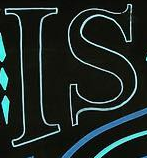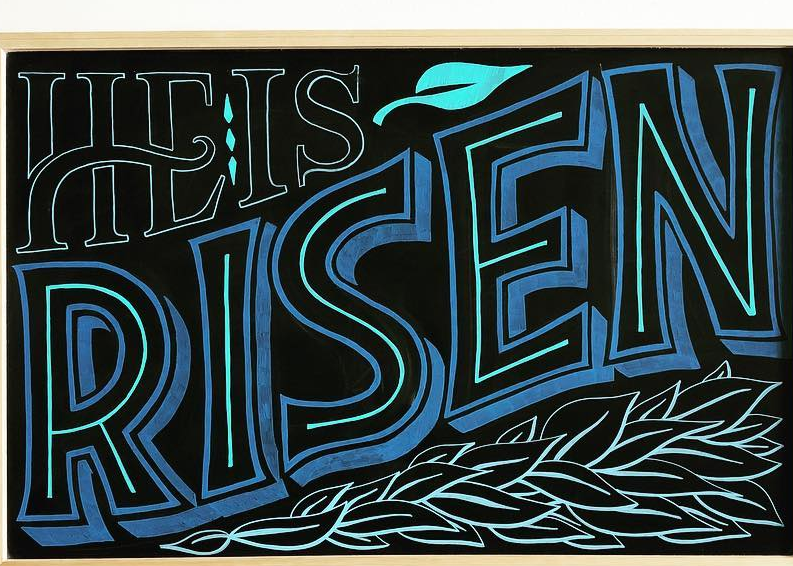Identify the words shown in these images in order, separated by a semicolon. IS; RISEN 